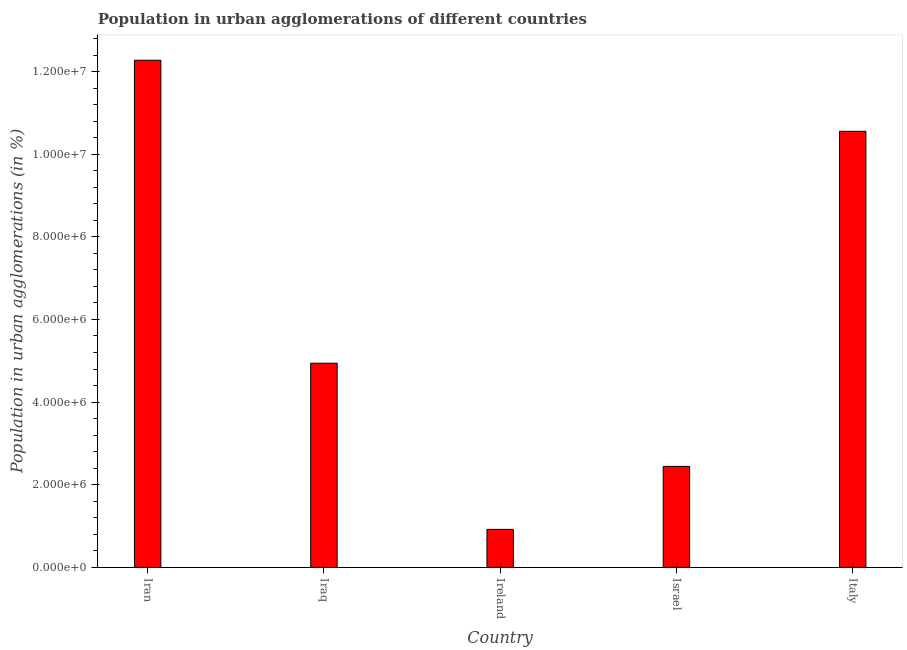What is the title of the graph?
Provide a short and direct response. Population in urban agglomerations of different countries. What is the label or title of the Y-axis?
Your answer should be very brief. Population in urban agglomerations (in %). What is the population in urban agglomerations in Iran?
Ensure brevity in your answer.  1.23e+07. Across all countries, what is the maximum population in urban agglomerations?
Give a very brief answer. 1.23e+07. Across all countries, what is the minimum population in urban agglomerations?
Keep it short and to the point. 9.20e+05. In which country was the population in urban agglomerations maximum?
Your answer should be compact. Iran. In which country was the population in urban agglomerations minimum?
Your response must be concise. Ireland. What is the sum of the population in urban agglomerations?
Give a very brief answer. 3.11e+07. What is the difference between the population in urban agglomerations in Ireland and Italy?
Your answer should be very brief. -9.63e+06. What is the average population in urban agglomerations per country?
Offer a terse response. 6.23e+06. What is the median population in urban agglomerations?
Offer a very short reply. 4.94e+06. In how many countries, is the population in urban agglomerations greater than 5600000 %?
Offer a terse response. 2. What is the ratio of the population in urban agglomerations in Iran to that in Israel?
Offer a terse response. 5.02. Is the population in urban agglomerations in Iran less than that in Israel?
Give a very brief answer. No. What is the difference between the highest and the second highest population in urban agglomerations?
Your response must be concise. 1.72e+06. What is the difference between the highest and the lowest population in urban agglomerations?
Give a very brief answer. 1.14e+07. In how many countries, is the population in urban agglomerations greater than the average population in urban agglomerations taken over all countries?
Give a very brief answer. 2. How many bars are there?
Provide a short and direct response. 5. Are all the bars in the graph horizontal?
Provide a short and direct response. No. How many countries are there in the graph?
Keep it short and to the point. 5. What is the difference between two consecutive major ticks on the Y-axis?
Keep it short and to the point. 2.00e+06. What is the Population in urban agglomerations (in %) in Iran?
Your answer should be compact. 1.23e+07. What is the Population in urban agglomerations (in %) in Iraq?
Your answer should be very brief. 4.94e+06. What is the Population in urban agglomerations (in %) in Ireland?
Provide a succinct answer. 9.20e+05. What is the Population in urban agglomerations (in %) in Israel?
Your answer should be compact. 2.44e+06. What is the Population in urban agglomerations (in %) in Italy?
Offer a terse response. 1.06e+07. What is the difference between the Population in urban agglomerations (in %) in Iran and Iraq?
Provide a succinct answer. 7.33e+06. What is the difference between the Population in urban agglomerations (in %) in Iran and Ireland?
Offer a very short reply. 1.14e+07. What is the difference between the Population in urban agglomerations (in %) in Iran and Israel?
Provide a short and direct response. 9.83e+06. What is the difference between the Population in urban agglomerations (in %) in Iran and Italy?
Your answer should be compact. 1.72e+06. What is the difference between the Population in urban agglomerations (in %) in Iraq and Ireland?
Your answer should be compact. 4.02e+06. What is the difference between the Population in urban agglomerations (in %) in Iraq and Israel?
Your answer should be very brief. 2.50e+06. What is the difference between the Population in urban agglomerations (in %) in Iraq and Italy?
Your response must be concise. -5.61e+06. What is the difference between the Population in urban agglomerations (in %) in Ireland and Israel?
Keep it short and to the point. -1.52e+06. What is the difference between the Population in urban agglomerations (in %) in Ireland and Italy?
Your answer should be compact. -9.63e+06. What is the difference between the Population in urban agglomerations (in %) in Israel and Italy?
Give a very brief answer. -8.11e+06. What is the ratio of the Population in urban agglomerations (in %) in Iran to that in Iraq?
Keep it short and to the point. 2.48. What is the ratio of the Population in urban agglomerations (in %) in Iran to that in Ireland?
Your response must be concise. 13.35. What is the ratio of the Population in urban agglomerations (in %) in Iran to that in Israel?
Your response must be concise. 5.02. What is the ratio of the Population in urban agglomerations (in %) in Iran to that in Italy?
Offer a very short reply. 1.16. What is the ratio of the Population in urban agglomerations (in %) in Iraq to that in Ireland?
Offer a very short reply. 5.37. What is the ratio of the Population in urban agglomerations (in %) in Iraq to that in Israel?
Provide a succinct answer. 2.02. What is the ratio of the Population in urban agglomerations (in %) in Iraq to that in Italy?
Ensure brevity in your answer.  0.47. What is the ratio of the Population in urban agglomerations (in %) in Ireland to that in Israel?
Offer a very short reply. 0.38. What is the ratio of the Population in urban agglomerations (in %) in Ireland to that in Italy?
Make the answer very short. 0.09. What is the ratio of the Population in urban agglomerations (in %) in Israel to that in Italy?
Offer a very short reply. 0.23. 